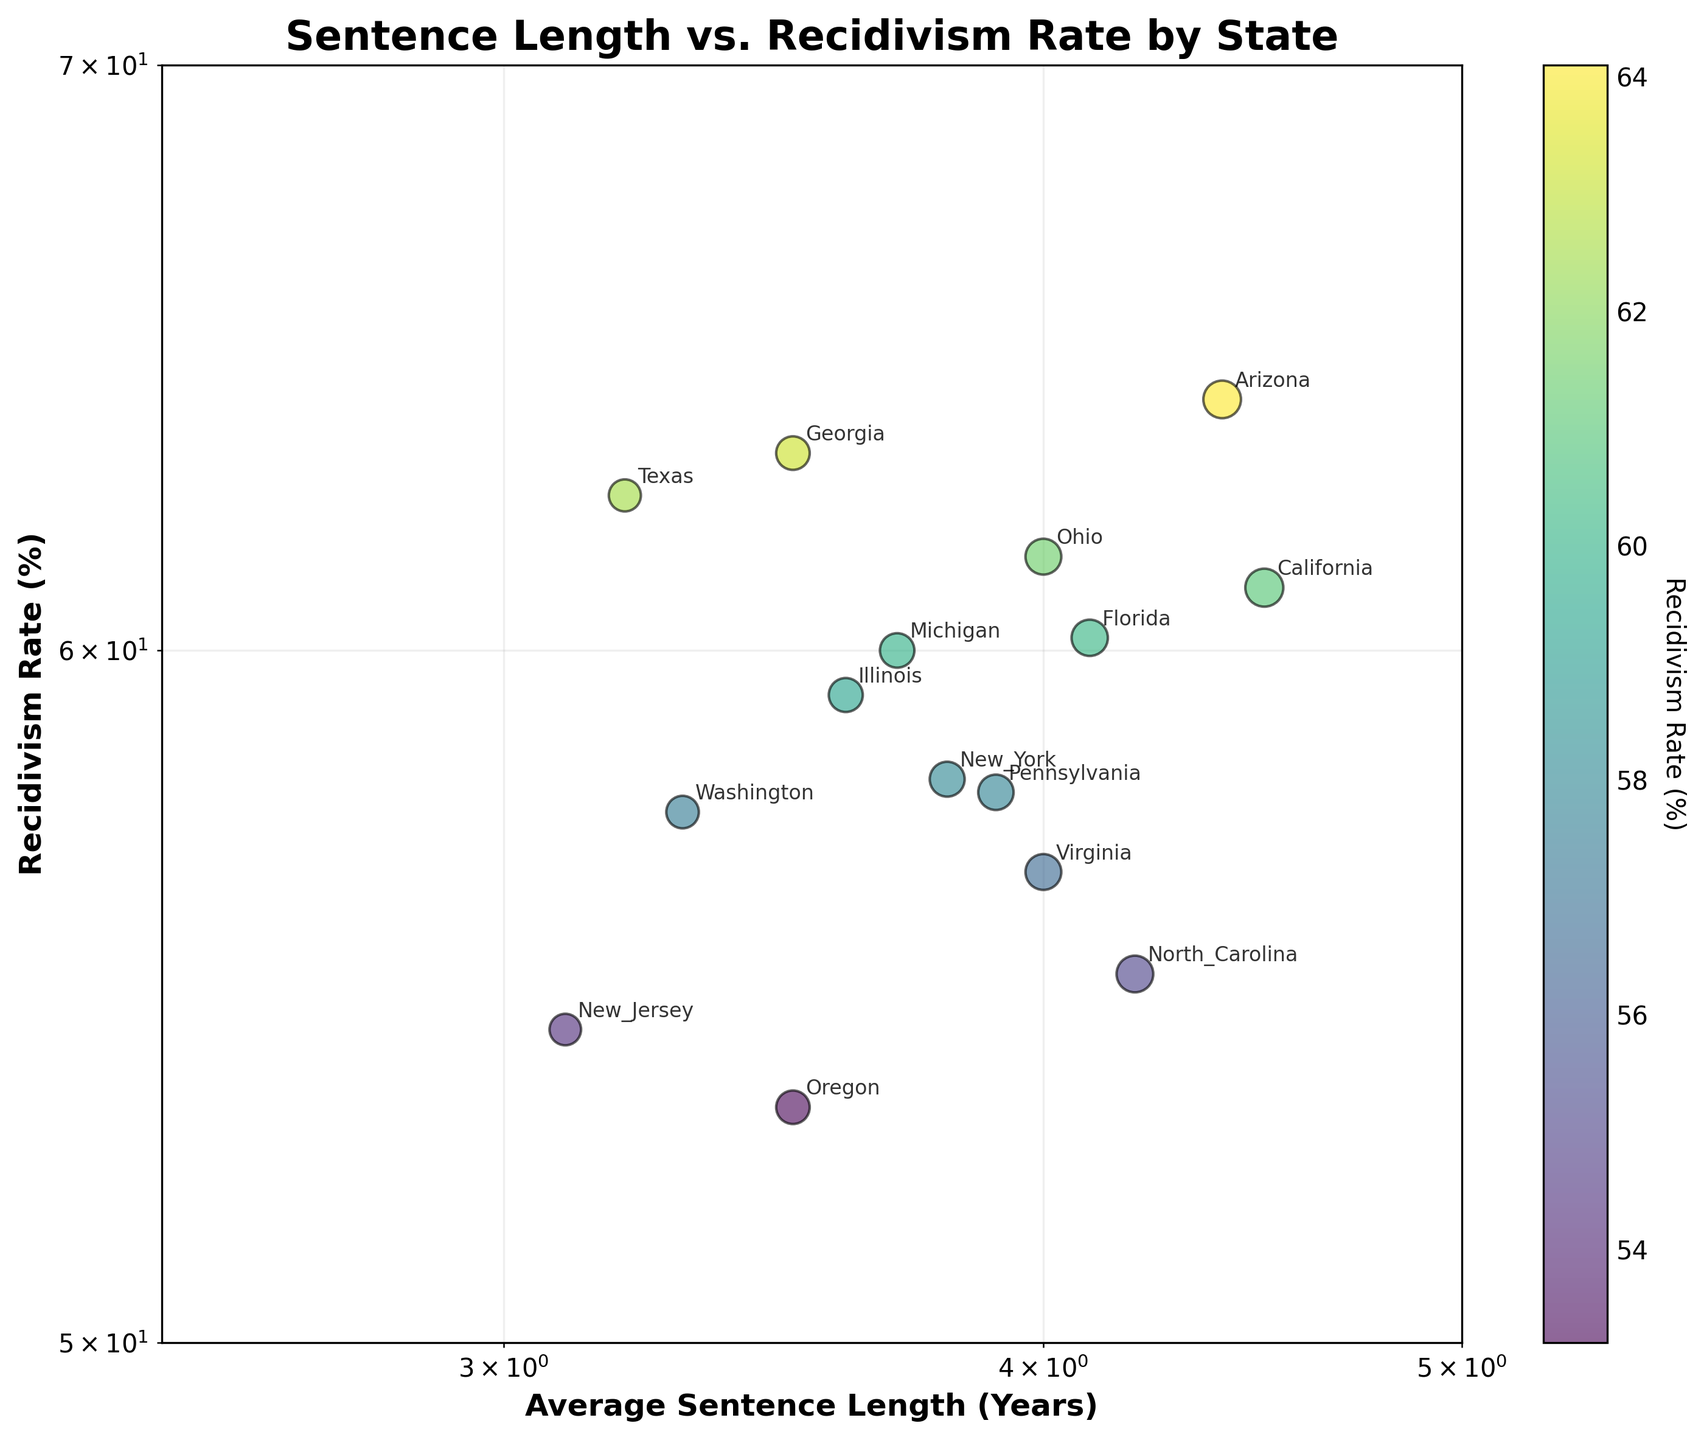What is the title of the plot? The title of a plot is usually shown at the top and summarizes what the plot represents.
Answer: Sentence Length vs. Recidivism Rate by State How many states have their data points shown on the plot? The number of data points on the scatter plot corresponds to the number of entries in the dataset, each represented by a unique dot.
Answer: 15 Which state has the highest recidivism rate? The state with the highest recidivism rate is identified by locating the data point that is the highest on the y-axis.
Answer: Arizona Which state has the lowest recidivism rate? The state with the lowest recidivism rate is found by locating the data point that is the lowest on the y-axis.
Answer: Oregon What is the range of average sentence length years in the plot? By examining the x-axis, we can see the minimum and maximum values for average sentence length, from the smallest to the largest value displayed.
Answer: 3.1 to 4.5 years Which state lies closest to the middle of the plot in terms of both sentence length and recidivism rate? The state closest to the middle would have mid-range values for both average sentence length and recidivism rate, which can be roughly estimated by finding the central point in the plot.
Answer: Pennsylvania How does the recidivism rate of California compare with New York? By locating the data points for both California and New York, we can compare their y-values to determine which state has a higher recidivism rate.
Answer: California has a higher recidivism rate than New York Is there a visible correlation between average sentence length and recidivism rate in the plot? To determine if there is a correlation, we look at the overall pattern of the scatter plot; if the points trend upward or downward together, a correlation might be present.
Answer: No clear correlation is visible Which state has the largest bubble on the plot? The size of the bubbles indicates the average sentence length, so the state with the largest bubble corresponds to the longest average sentence on the x-axis.
Answer: Arizona What color represents the highest recidivism rate and which state does it represent? The color bar indicates the relationship between color intensity and recidivism rates; the darkest hue represents the highest rate. We match this with the state having the highest data point.
Answer: Purple color represents the highest recidivism rate, and it corresponds to Arizona 